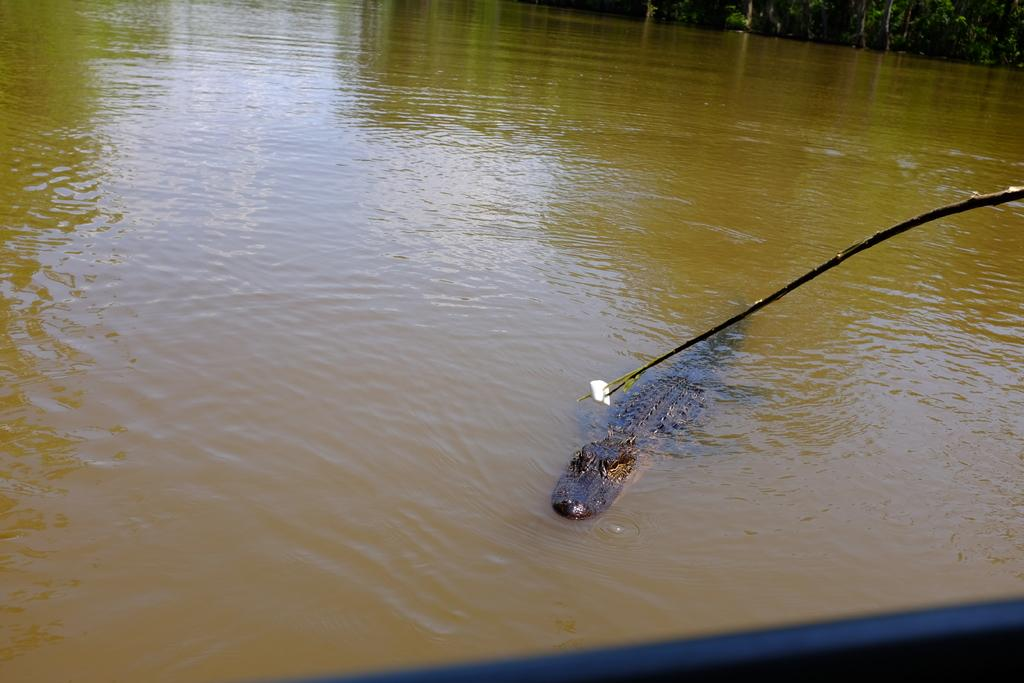What animal can be seen in the water in the image? There is a crocodile in the water in the image. What can be seen in the background of the image? There are trees in the background of the image. What type of suit is the crocodile wearing in the image? The crocodile is not wearing a suit in the image, as it is an animal and does not wear clothing. 